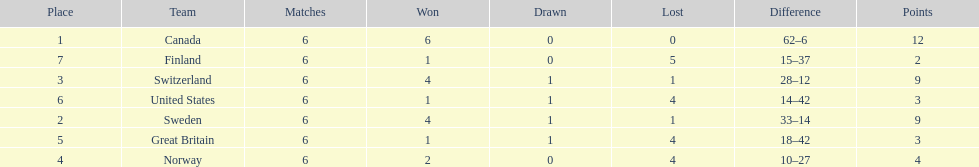What is the total number of teams to have 4 total wins? 2. 